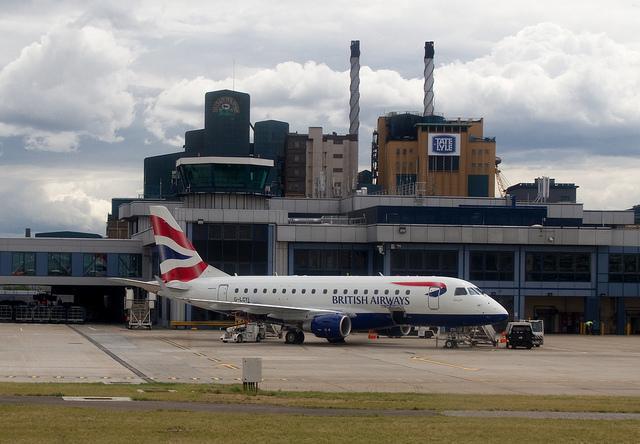How many smoke stacks are in the background?
Give a very brief answer. 2. 